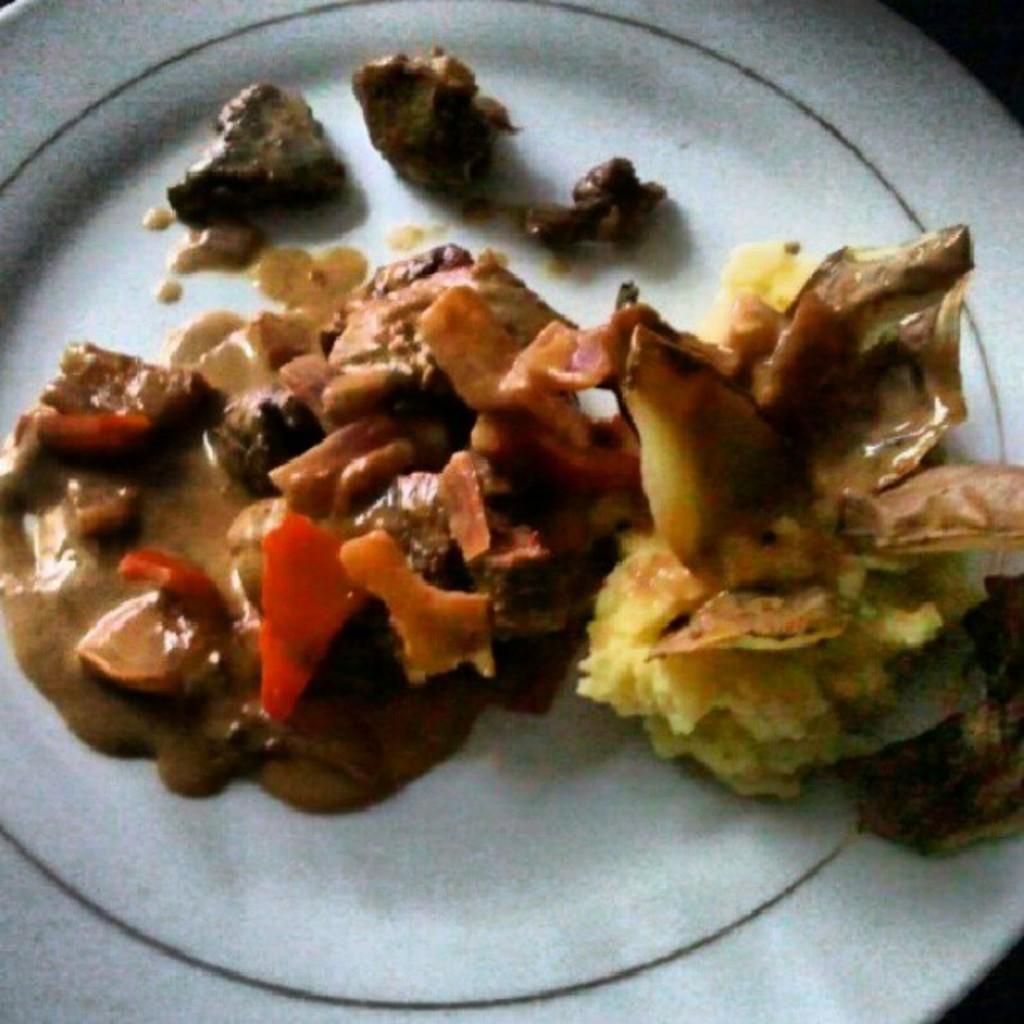Could you give a brief overview of what you see in this image? In this image there is some food item on a plate. 